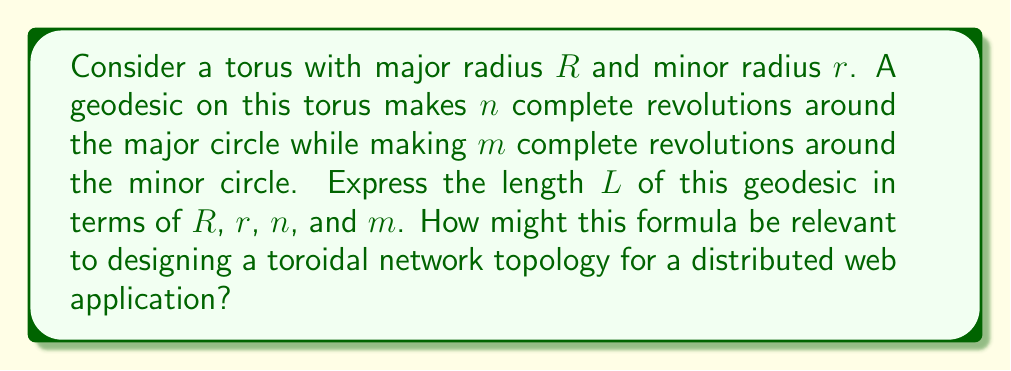Show me your answer to this math problem. Let's approach this step-by-step:

1) First, recall that a geodesic on a torus can be represented parametrically as:

   $$x = (R + r\cos\theta)\cos\phi$$
   $$y = (R + r\cos\theta)\sin\phi$$
   $$z = r\sin\theta$$

   where $\theta$ and $\phi$ are parameters.

2) For a geodesic that makes $n$ revolutions around the major circle and $m$ revolutions around the minor circle, we can express $\theta$ and $\phi$ as:

   $$\theta = \frac{2\pi m t}{T}, \phi = \frac{2\pi n t}{T}$$

   where $t$ is a parameter and $T$ is the total "time" for one complete cycle of the geodesic.

3) The length of the geodesic is given by the line integral:

   $$L = \int_0^T \sqrt{\left(\frac{dx}{dt}\right)^2 + \left(\frac{dy}{dt}\right)^2 + \left(\frac{dz}{dt}\right)^2} dt$$

4) After substituting and simplifying, we get:

   $$L = \int_0^T \sqrt{(R + r\cos\theta)^2\left(\frac{d\phi}{dt}\right)^2 + r^2\left(\frac{d\theta}{dt}\right)^2} dt$$

5) Substituting the expressions for $\theta$ and $\phi$:

   $$L = \int_0^T \sqrt{\left(\frac{2\pi n}{T}\right)^2(R + r\cos(\frac{2\pi m t}{T}))^2 + \left(\frac{2\pi m r}{T}\right)^2} dt$$

6) This integral can be evaluated to:

   $$L = 2\pi\sqrt{n^2R^2 + m^2r^2}$$

This formula is relevant to designing a toroidal network topology for a distributed web application in several ways:

1) It provides a measure of the "distance" between nodes in the network, which could be used to optimize data routing.

2) The ratio of $n$ to $m$ could be adjusted to balance the trade-off between local and global connectivity in the network.

3) Understanding the properties of geodesics on a torus can help in designing efficient algorithms for data distribution and load balancing in a toroidal network.

4) For a C++ developer, this formula could be implemented as part of a network simulation or optimization algorithm.
Answer: $L = 2\pi\sqrt{n^2R^2 + m^2r^2}$ 